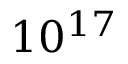Convert formula to latex. <formula><loc_0><loc_0><loc_500><loc_500>1 0 ^ { 1 7 }</formula> 